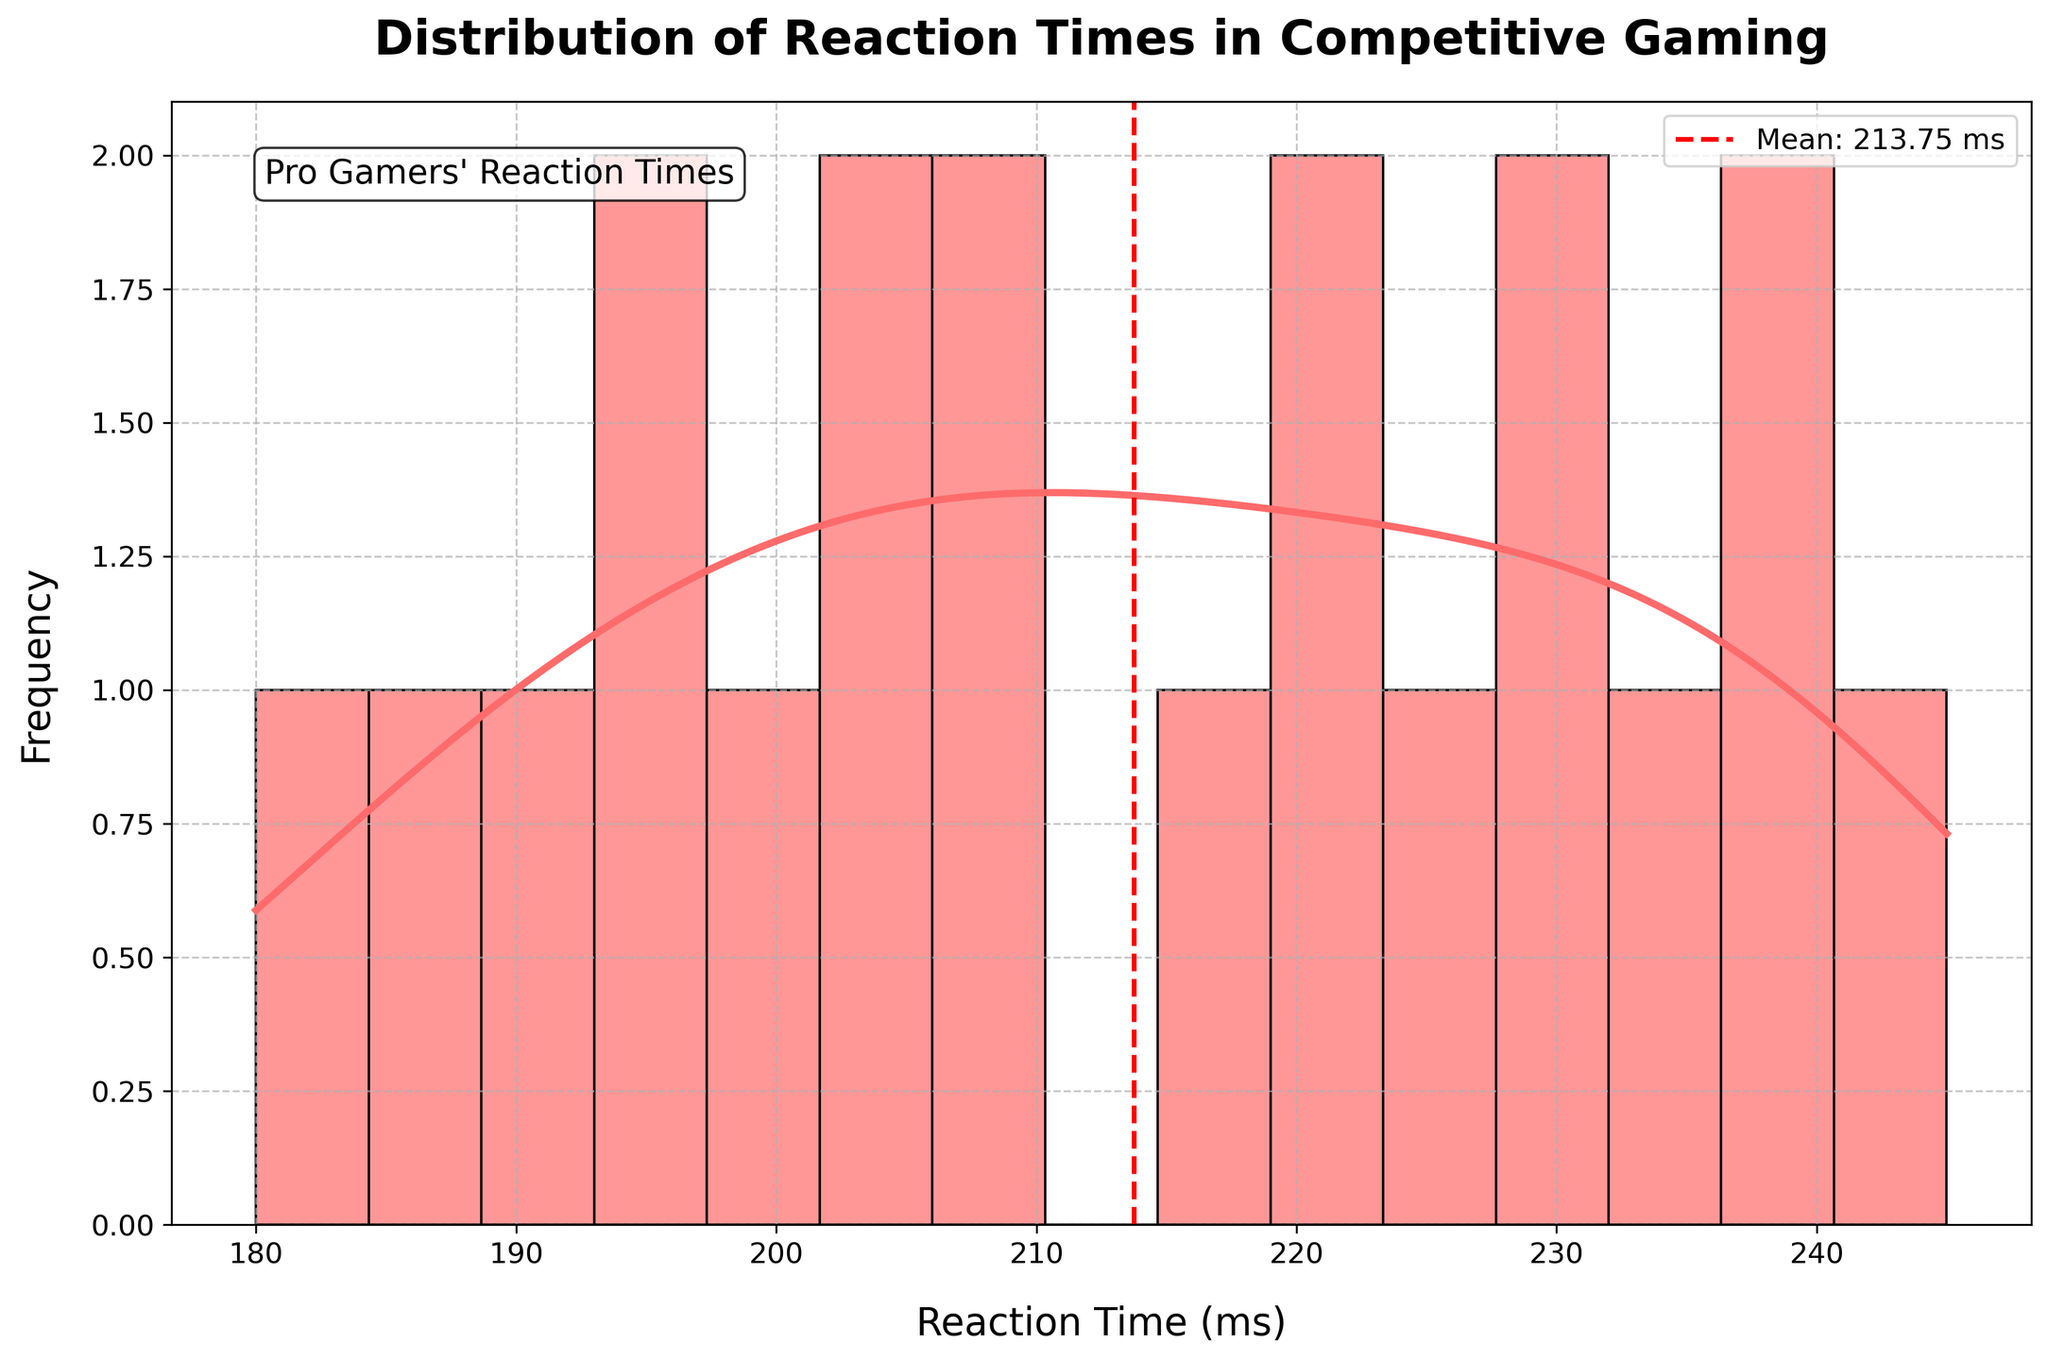What is the title of the plot? The title of the plot is located at the top center. It reads "Distribution of Reaction Times in Competitive Gaming" in bold font.
Answer: Distribution of Reaction Times in Competitive Gaming What does the x-axis represent in the histogram? The x-axis is labeled as "Reaction Time (ms)", indicating that it represents the reaction times measured in milliseconds.
Answer: Reaction Time (ms) What is the mean reaction time shown by the dashed red line? The mean reaction time is indicated by the red dashed vertical line, which is also labeled with the mean value.
Answer: Mean: 211.75 ms Which reaction time range appears to be the most frequent? To find the most frequent range, look at the highest bars in the histogram. This range appears to be around 200 to 210 milliseconds.
Answer: 200-210 ms How many bins are used in the histogram? By counting the number of bars in the histogram, we can see that there are 15 bins.
Answer: 15 What is the general trend of the density curve (KDE) in the histogram? The density curve shows the probability density of reaction times. It starts low, increases to a peak around 205 ms, and then decreases beyond 210 ms.
Answer: Increases to a peak around 205 ms, then decreases Are there any reaction times that are noticeably higher than the mean? By looking at the histogram and noting the position of the mean as indicated by the red dashed line, the reaction times above 235 ms are noticeably higher than the mean.
Answer: Above 235 ms How does the reaction time of 245 ms compare to the peak of the density curve? The reaction time of 245 ms is located near the right tail of the histogram and is lower than the peak of the KDE, indicating it is less frequent.
Answer: Lower than the peak What can be inferred about reaction times less than 185 ms? The histogram shows very few or no bars in the range below 185 ms, indicating very few players have reaction times less than 185 ms.
Answer: Very few players have reaction times less than 185 ms Which game's players have reaction times closest to the peak of the KDE? The reaction time near the peak of the KDE is around 205 ms. The players from Valorant (Mixwell with 210 ms and ScreaM with 190 ms) along with Fortnite (Bugha with 205 ms and Myth with 225 ms) are closest.
Answer: Valorant and Fortnite 